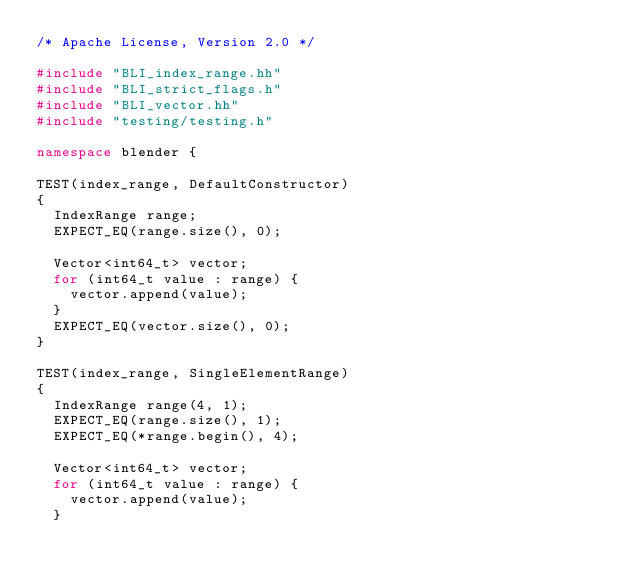Convert code to text. <code><loc_0><loc_0><loc_500><loc_500><_C++_>/* Apache License, Version 2.0 */

#include "BLI_index_range.hh"
#include "BLI_strict_flags.h"
#include "BLI_vector.hh"
#include "testing/testing.h"

namespace blender {

TEST(index_range, DefaultConstructor)
{
  IndexRange range;
  EXPECT_EQ(range.size(), 0);

  Vector<int64_t> vector;
  for (int64_t value : range) {
    vector.append(value);
  }
  EXPECT_EQ(vector.size(), 0);
}

TEST(index_range, SingleElementRange)
{
  IndexRange range(4, 1);
  EXPECT_EQ(range.size(), 1);
  EXPECT_EQ(*range.begin(), 4);

  Vector<int64_t> vector;
  for (int64_t value : range) {
    vector.append(value);
  }
</code> 